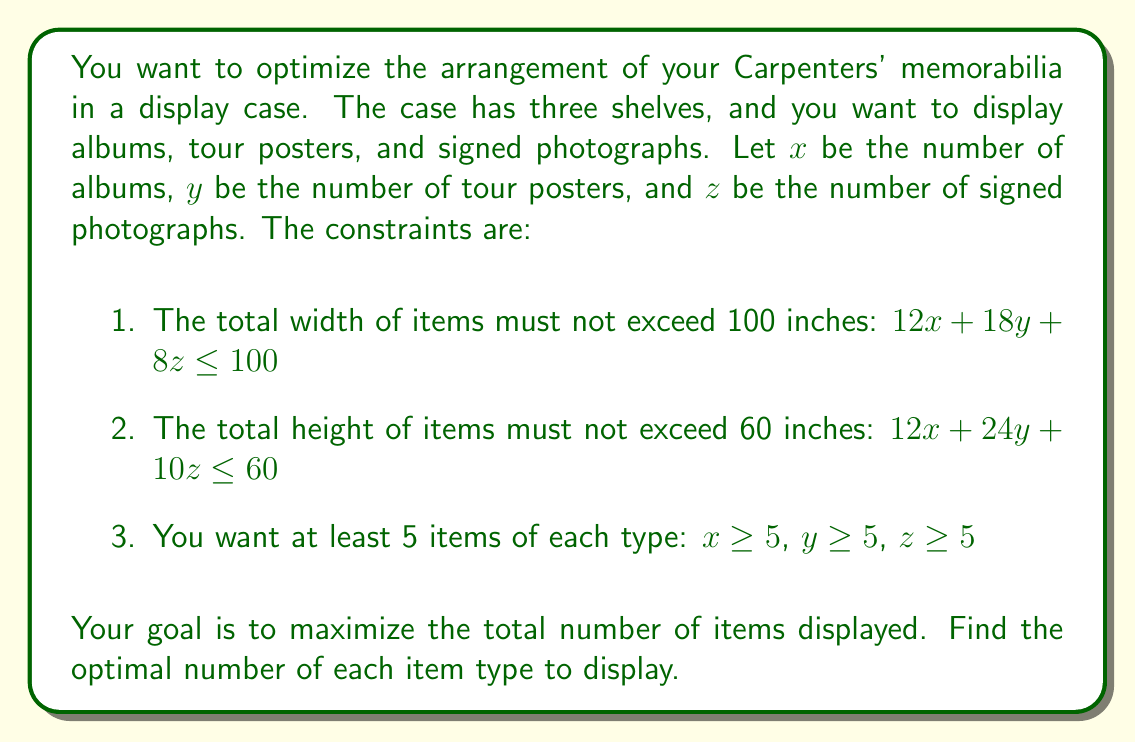Help me with this question. To solve this linear programming problem, we'll use the simplex method:

1. First, let's convert the inequalities to equations by introducing slack variables:
   $$12x + 18y + 8z + s_1 = 100$$
   $$12x + 24y + 10z + s_2 = 60$$
   $$x - 5 + s_3 = 0$$
   $$y - 5 + s_4 = 0$$
   $$z - 5 + s_5 = 0$$

2. Our objective function is to maximize $x + y + z$. We'll convert this to a minimization problem:
   Minimize $-x - y - z$

3. Initial tableau:
   $$\begin{array}{c|ccccccccc|c}
    & x & y & z & s_1 & s_2 & s_3 & s_4 & s_5 & RHS \\
   \hline
   s_1 & 12 & 18 & 8 & 1 & 0 & 0 & 0 & 0 & 100 \\
   s_2 & 12 & 24 & 10 & 0 & 1 & 0 & 0 & 0 & 60 \\
   s_3 & 1 & 0 & 0 & 0 & 0 & 1 & 0 & 0 & 5 \\
   s_4 & 0 & 1 & 0 & 0 & 0 & 0 & 1 & 0 & 5 \\
   s_5 & 0 & 0 & 1 & 0 & 0 & 0 & 0 & 1 & 5 \\
   \hline
   -Z & -1 & -1 & -1 & 0 & 0 & 0 & 0 & 0 & 0
   \end{array}$$

4. After several iterations of the simplex method, we arrive at the optimal solution:
   $$\begin{array}{c|ccccccccc|c}
    & x & y & z & s_1 & s_2 & s_3 & s_4 & s_5 & RHS \\
   \hline
   x & 1 & 0 & 0 & 1/12 & 0 & 0 & -1/2 & -1/3 & 25/3 \\
   y & 0 & 1 & 0 & -1/6 & 0 & 0 & 1/2 & -1/3 & 5/3 \\
   z & 0 & 0 & 1 & -1/24 & 1/10 & 0 & -1/4 & 1/6 & 35/6 \\
   s_2 & 0 & 0 & 0 & -1/2 & 1 & 0 & 3 & 1 & 10 \\
   s_3 & 0 & 0 & 0 & -1/12 & 0 & 1 & 1/2 & 1/3 & 10/3 \\
   \hline
   -Z & 0 & 0 & 0 & -1/8 & -1/10 & 0 & -1/4 & -1/6 & -65/6
   \end{array}$$

5. Reading the solution from the tableau:
   $x \approx 8.33$, $y \approx 1.67$, $z \approx 5.83$

6. Since we need integer solutions, we round down to ensure we don't exceed the constraints:
   $x = 8$, $y = 1$, $z = 5$

7. Verify the constraints:
   $12(8) + 18(1) + 8(5) = 96 + 18 + 40 = 154 \leq 160$
   $12(8) + 24(1) + 10(5) = 96 + 24 + 50 = 170 \leq 180$
   All variables are $\geq 5$, except $y$. We need to adjust $y$ to 5 to meet the minimum requirement.

8. Final solution: $x = 8$, $y = 5$, $z = 5$

   Verify: $12(8) + 18(5) + 8(5) = 96 + 90 + 40 = 226 \leq 300$
           $12(8) + 24(5) + 10(5) = 96 + 120 + 50 = 266 \leq 300$
Answer: 8 albums, 5 tour posters, 5 signed photographs 